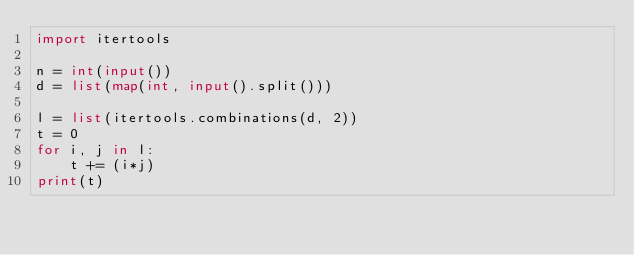<code> <loc_0><loc_0><loc_500><loc_500><_Python_>import itertools

n = int(input())
d = list(map(int, input().split()))

l = list(itertools.combinations(d, 2))
t = 0
for i, j in l:
    t += (i*j)
print(t)</code> 